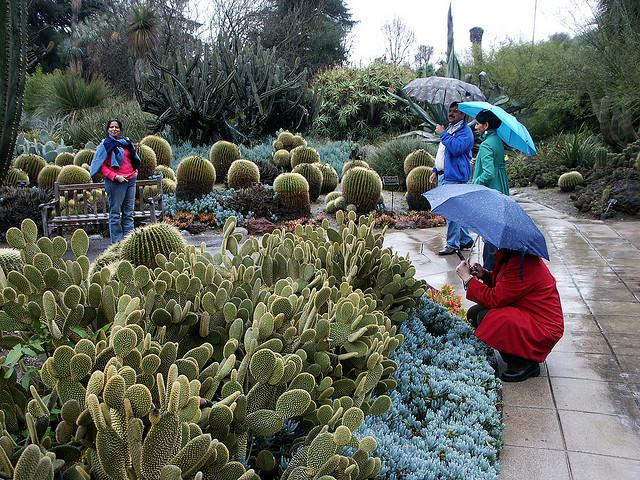What do these plants need very little of? water 